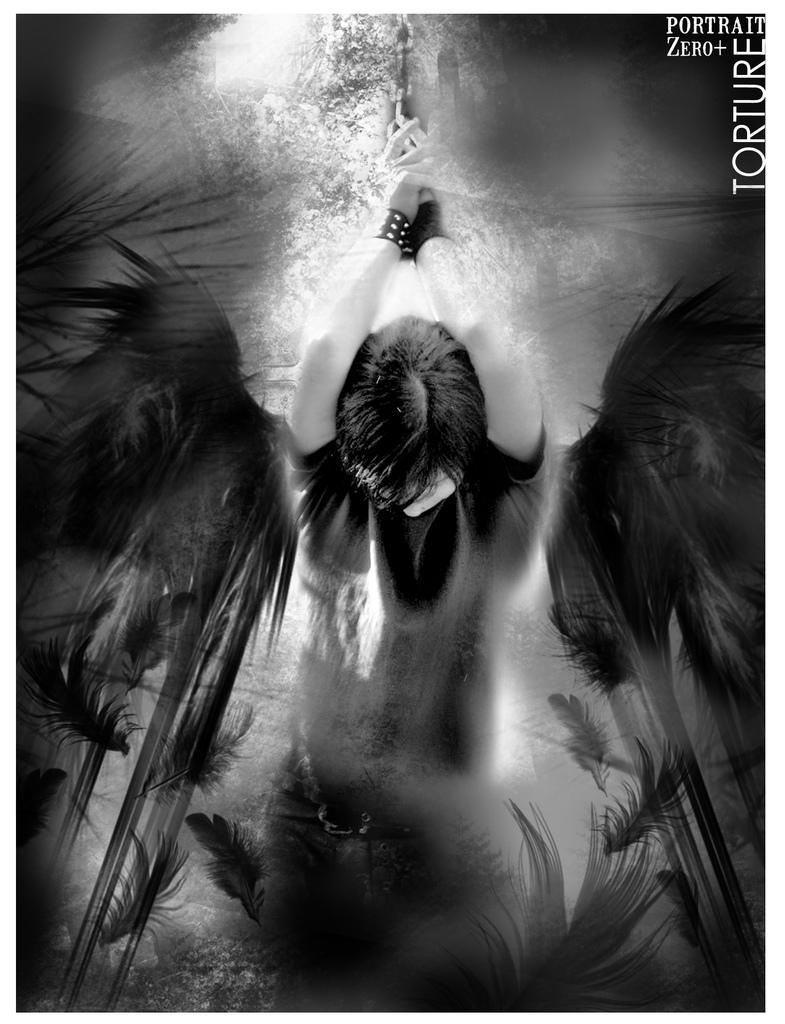What is the main subject of the image? The main subject of the image is an edited picture of a person. What type of natural scenery is visible in the image? There are trees in the image. Is there any text present in the image? Yes, there is text on the image. What type of doll can be seen holding a piece of beef in the image? There is no doll or beef present in the image; it features an edited picture of a person with trees and text. Is there a letter addressed to the person in the image? The provided facts do not mention a letter or any form of written communication in the image. 